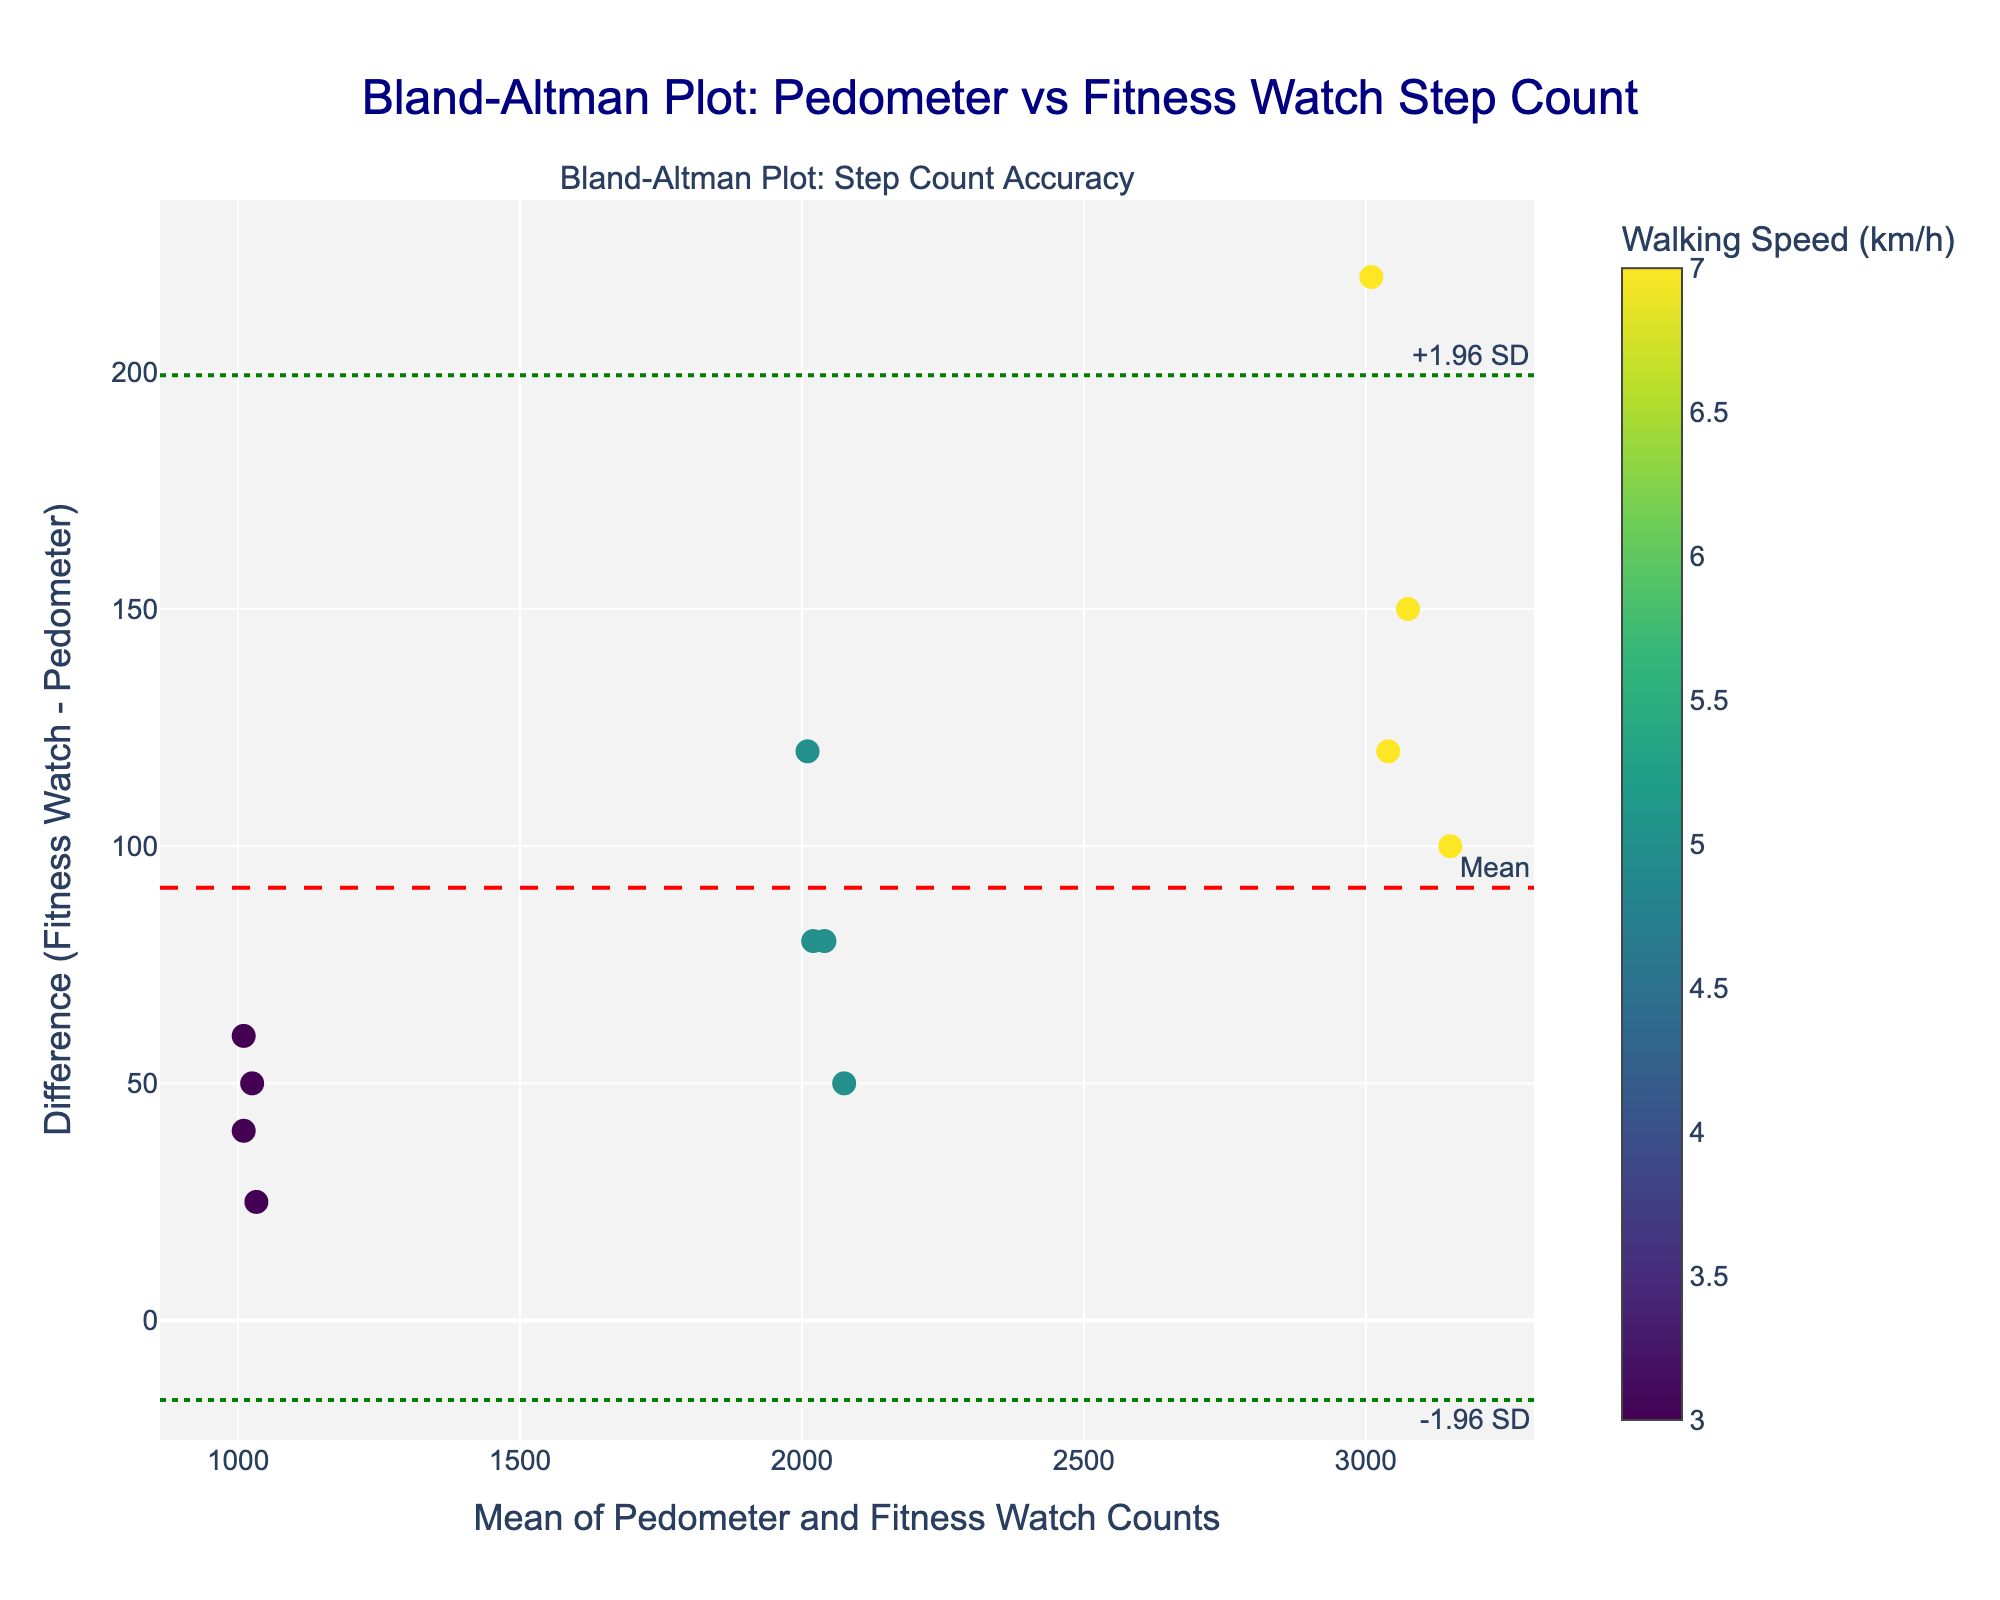What is the title of the plot? The title is usually found at the top of the plot, clearly indicating the purpose or focus of the figure.
Answer: Bland-Altman Plot: Pedometer vs Fitness Watch Step Count What are the axes titles of the plot? The axes titles are shown alongside the axes and describe what each axis represents. The x-axis title is at the bottom and the y-axis title is on the left side.
Answer: Mean of Pedometer and Fitness Watch Counts (x-axis); Difference (Fitness Watch - Pedometer) (y-axis) What does the red dashed line represent? The legend or annotation in the plot indicates that the red dashed line represents the mean difference between the fitness watch count and pedometer count.
Answer: Mean difference How many walking speeds are included in the plot, and how are they represented? Walking speeds are indicated by the color scale on the right side of the plot which shows different colors for different speeds.
Answer: Three speeds: 3 km/h, 5 km/h, 7 km/h Which device shows the smallest difference at a walking speed of 5 km/h? To find this, identify the color corresponding to 5 km/h (as indicated in the color scale) and look for the smallest difference (the closest point to the x-axis)
Answer: Omron HJ-325 What are the limits of agreement in this plot? The limits of agreement are shown by the two dotted green lines. Their y-values are annotated alongside the lines as +1.96 SD and -1.96 SD respectively.
Answer: Mean difference ± 1.96 SD How does the step count difference vary with walking speed? By observing the color gradient of the points from lower to higher walking speeds along the y-axis (difference), you can describe the general trend.
Answer: The difference tends to increase with walking speed What is the average count range represented in the plot? This can be interpreted by looking at the x-axis range, which shows the mean step counts of pedometer and fitness watch.
Answer: About 1000 to 3150 steps Which device exhibits the highest variation in difference at 7 km/h? The variation in difference can be recognized by seeing which points, at the color of 7 km/h, are farthest spread apart on the y-axis.
Answer: Omron HJ-325 Are there any devices that consistently underestimate or overestimate the step count compared to the fitness watch across all speeds? Consistently one direction of difference would show if one device's points are always above or below the x-axis.
Answer: No, the differences vary across devices and speeds 